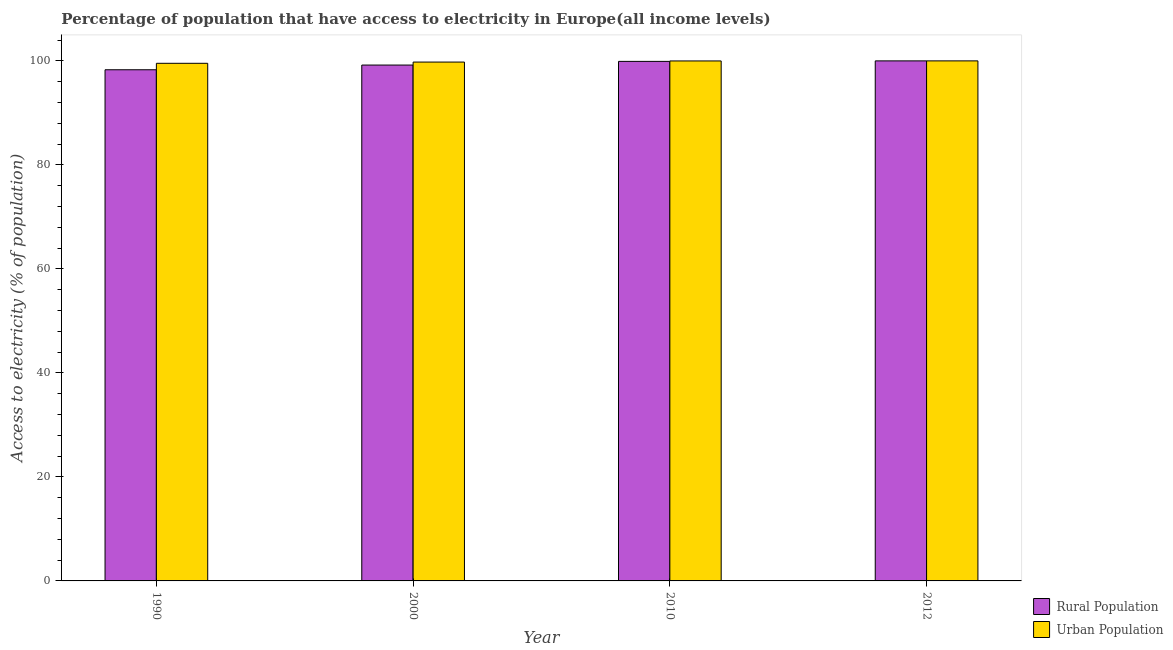How many different coloured bars are there?
Your answer should be very brief. 2. How many groups of bars are there?
Offer a terse response. 4. Are the number of bars per tick equal to the number of legend labels?
Make the answer very short. Yes. Are the number of bars on each tick of the X-axis equal?
Your answer should be very brief. Yes. How many bars are there on the 2nd tick from the left?
Provide a succinct answer. 2. What is the percentage of rural population having access to electricity in 1990?
Your answer should be very brief. 98.29. Across all years, what is the minimum percentage of rural population having access to electricity?
Ensure brevity in your answer.  98.29. In which year was the percentage of rural population having access to electricity maximum?
Your answer should be very brief. 2012. What is the total percentage of rural population having access to electricity in the graph?
Give a very brief answer. 397.39. What is the difference between the percentage of rural population having access to electricity in 1990 and that in 2000?
Ensure brevity in your answer.  -0.91. What is the difference between the percentage of rural population having access to electricity in 2000 and the percentage of urban population having access to electricity in 2010?
Your answer should be compact. -0.71. What is the average percentage of urban population having access to electricity per year?
Give a very brief answer. 99.82. In the year 1990, what is the difference between the percentage of rural population having access to electricity and percentage of urban population having access to electricity?
Make the answer very short. 0. In how many years, is the percentage of urban population having access to electricity greater than 8 %?
Provide a succinct answer. 4. What is the ratio of the percentage of rural population having access to electricity in 2000 to that in 2012?
Offer a terse response. 0.99. What is the difference between the highest and the second highest percentage of urban population having access to electricity?
Offer a very short reply. 0.01. What is the difference between the highest and the lowest percentage of rural population having access to electricity?
Your answer should be very brief. 1.71. In how many years, is the percentage of rural population having access to electricity greater than the average percentage of rural population having access to electricity taken over all years?
Your answer should be compact. 2. Is the sum of the percentage of urban population having access to electricity in 1990 and 2000 greater than the maximum percentage of rural population having access to electricity across all years?
Ensure brevity in your answer.  Yes. What does the 2nd bar from the left in 1990 represents?
Your answer should be compact. Urban Population. What does the 1st bar from the right in 2010 represents?
Ensure brevity in your answer.  Urban Population. How many bars are there?
Give a very brief answer. 8. Are all the bars in the graph horizontal?
Your response must be concise. No. Does the graph contain any zero values?
Make the answer very short. No. Does the graph contain grids?
Your answer should be compact. No. Where does the legend appear in the graph?
Ensure brevity in your answer.  Bottom right. What is the title of the graph?
Give a very brief answer. Percentage of population that have access to electricity in Europe(all income levels). What is the label or title of the Y-axis?
Offer a very short reply. Access to electricity (% of population). What is the Access to electricity (% of population) in Rural Population in 1990?
Give a very brief answer. 98.29. What is the Access to electricity (% of population) in Urban Population in 1990?
Your answer should be very brief. 99.53. What is the Access to electricity (% of population) of Rural Population in 2000?
Your answer should be very brief. 99.2. What is the Access to electricity (% of population) of Urban Population in 2000?
Offer a very short reply. 99.77. What is the Access to electricity (% of population) of Rural Population in 2010?
Offer a very short reply. 99.9. What is the Access to electricity (% of population) of Urban Population in 2010?
Provide a short and direct response. 99.99. What is the Access to electricity (% of population) of Urban Population in 2012?
Give a very brief answer. 100. Across all years, what is the maximum Access to electricity (% of population) of Rural Population?
Make the answer very short. 100. Across all years, what is the maximum Access to electricity (% of population) in Urban Population?
Keep it short and to the point. 100. Across all years, what is the minimum Access to electricity (% of population) in Rural Population?
Make the answer very short. 98.29. Across all years, what is the minimum Access to electricity (% of population) of Urban Population?
Offer a terse response. 99.53. What is the total Access to electricity (% of population) of Rural Population in the graph?
Offer a terse response. 397.39. What is the total Access to electricity (% of population) of Urban Population in the graph?
Offer a very short reply. 399.29. What is the difference between the Access to electricity (% of population) in Rural Population in 1990 and that in 2000?
Make the answer very short. -0.91. What is the difference between the Access to electricity (% of population) in Urban Population in 1990 and that in 2000?
Give a very brief answer. -0.24. What is the difference between the Access to electricity (% of population) of Rural Population in 1990 and that in 2010?
Provide a succinct answer. -1.61. What is the difference between the Access to electricity (% of population) of Urban Population in 1990 and that in 2010?
Offer a very short reply. -0.45. What is the difference between the Access to electricity (% of population) of Rural Population in 1990 and that in 2012?
Make the answer very short. -1.71. What is the difference between the Access to electricity (% of population) of Urban Population in 1990 and that in 2012?
Your answer should be very brief. -0.46. What is the difference between the Access to electricity (% of population) in Rural Population in 2000 and that in 2010?
Offer a terse response. -0.71. What is the difference between the Access to electricity (% of population) of Urban Population in 2000 and that in 2010?
Offer a very short reply. -0.22. What is the difference between the Access to electricity (% of population) in Rural Population in 2000 and that in 2012?
Offer a very short reply. -0.8. What is the difference between the Access to electricity (% of population) in Urban Population in 2000 and that in 2012?
Give a very brief answer. -0.23. What is the difference between the Access to electricity (% of population) in Rural Population in 2010 and that in 2012?
Your response must be concise. -0.1. What is the difference between the Access to electricity (% of population) in Urban Population in 2010 and that in 2012?
Provide a succinct answer. -0.01. What is the difference between the Access to electricity (% of population) in Rural Population in 1990 and the Access to electricity (% of population) in Urban Population in 2000?
Provide a short and direct response. -1.48. What is the difference between the Access to electricity (% of population) in Rural Population in 1990 and the Access to electricity (% of population) in Urban Population in 2010?
Ensure brevity in your answer.  -1.69. What is the difference between the Access to electricity (% of population) of Rural Population in 1990 and the Access to electricity (% of population) of Urban Population in 2012?
Your answer should be compact. -1.71. What is the difference between the Access to electricity (% of population) in Rural Population in 2000 and the Access to electricity (% of population) in Urban Population in 2010?
Offer a terse response. -0.79. What is the difference between the Access to electricity (% of population) in Rural Population in 2000 and the Access to electricity (% of population) in Urban Population in 2012?
Keep it short and to the point. -0.8. What is the difference between the Access to electricity (% of population) in Rural Population in 2010 and the Access to electricity (% of population) in Urban Population in 2012?
Ensure brevity in your answer.  -0.09. What is the average Access to electricity (% of population) in Rural Population per year?
Keep it short and to the point. 99.35. What is the average Access to electricity (% of population) in Urban Population per year?
Provide a short and direct response. 99.82. In the year 1990, what is the difference between the Access to electricity (% of population) of Rural Population and Access to electricity (% of population) of Urban Population?
Your answer should be very brief. -1.24. In the year 2000, what is the difference between the Access to electricity (% of population) in Rural Population and Access to electricity (% of population) in Urban Population?
Offer a very short reply. -0.57. In the year 2010, what is the difference between the Access to electricity (% of population) in Rural Population and Access to electricity (% of population) in Urban Population?
Ensure brevity in your answer.  -0.08. In the year 2012, what is the difference between the Access to electricity (% of population) in Rural Population and Access to electricity (% of population) in Urban Population?
Ensure brevity in your answer.  0. What is the ratio of the Access to electricity (% of population) of Rural Population in 1990 to that in 2000?
Provide a short and direct response. 0.99. What is the ratio of the Access to electricity (% of population) in Urban Population in 1990 to that in 2000?
Ensure brevity in your answer.  1. What is the ratio of the Access to electricity (% of population) in Rural Population in 1990 to that in 2010?
Offer a very short reply. 0.98. What is the ratio of the Access to electricity (% of population) of Rural Population in 1990 to that in 2012?
Provide a short and direct response. 0.98. What is the ratio of the Access to electricity (% of population) of Urban Population in 1990 to that in 2012?
Give a very brief answer. 1. What is the ratio of the Access to electricity (% of population) of Rural Population in 2000 to that in 2010?
Give a very brief answer. 0.99. What is the ratio of the Access to electricity (% of population) in Urban Population in 2000 to that in 2010?
Make the answer very short. 1. What is the ratio of the Access to electricity (% of population) in Rural Population in 2000 to that in 2012?
Your response must be concise. 0.99. What is the ratio of the Access to electricity (% of population) of Rural Population in 2010 to that in 2012?
Offer a terse response. 1. What is the difference between the highest and the second highest Access to electricity (% of population) of Rural Population?
Your response must be concise. 0.1. What is the difference between the highest and the second highest Access to electricity (% of population) in Urban Population?
Your answer should be compact. 0.01. What is the difference between the highest and the lowest Access to electricity (% of population) of Rural Population?
Offer a very short reply. 1.71. What is the difference between the highest and the lowest Access to electricity (% of population) of Urban Population?
Offer a very short reply. 0.46. 